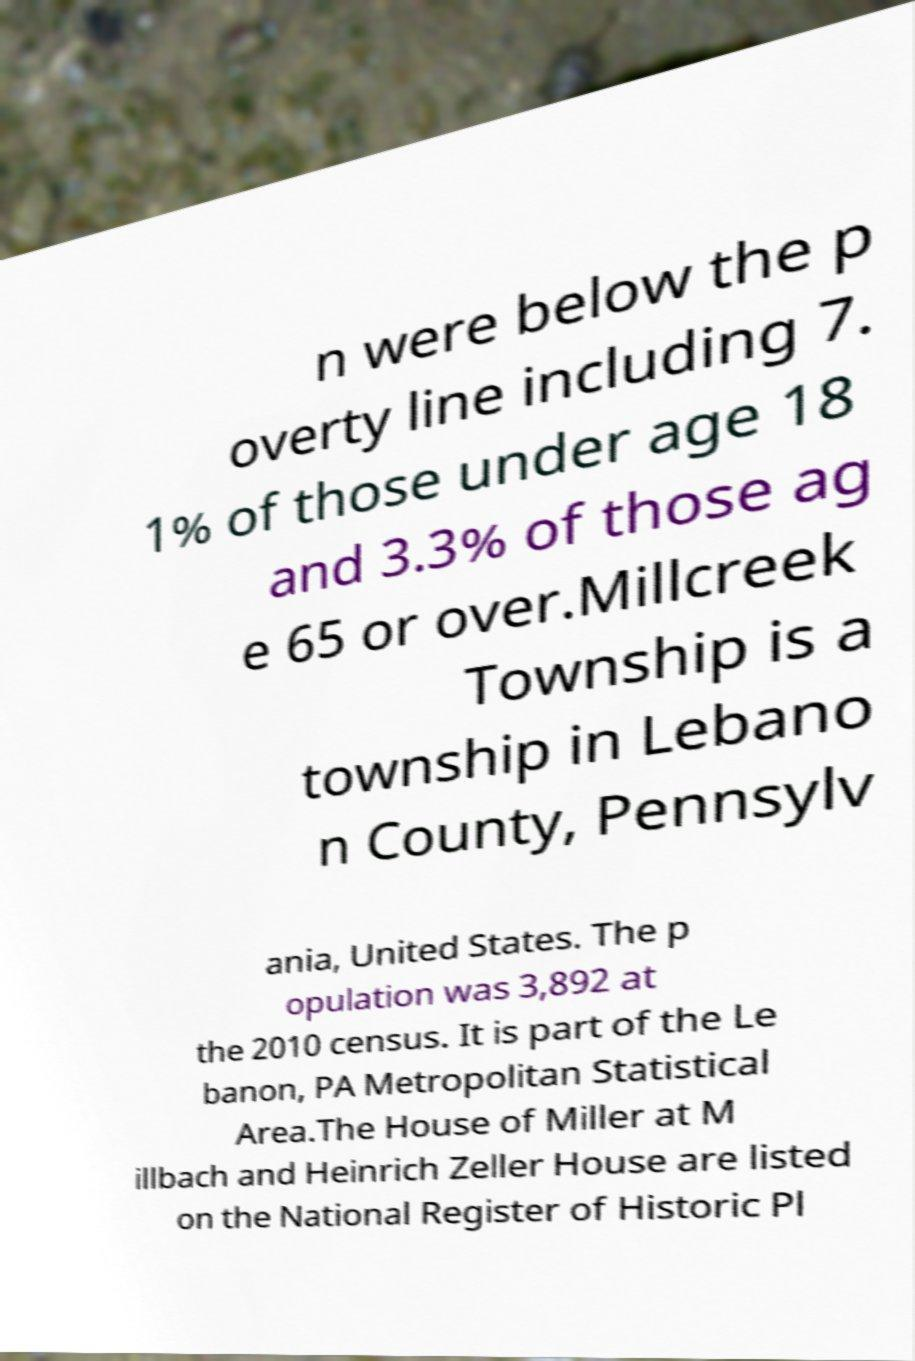Can you read and provide the text displayed in the image?This photo seems to have some interesting text. Can you extract and type it out for me? n were below the p overty line including 7. 1% of those under age 18 and 3.3% of those ag e 65 or over.Millcreek Township is a township in Lebano n County, Pennsylv ania, United States. The p opulation was 3,892 at the 2010 census. It is part of the Le banon, PA Metropolitan Statistical Area.The House of Miller at M illbach and Heinrich Zeller House are listed on the National Register of Historic Pl 